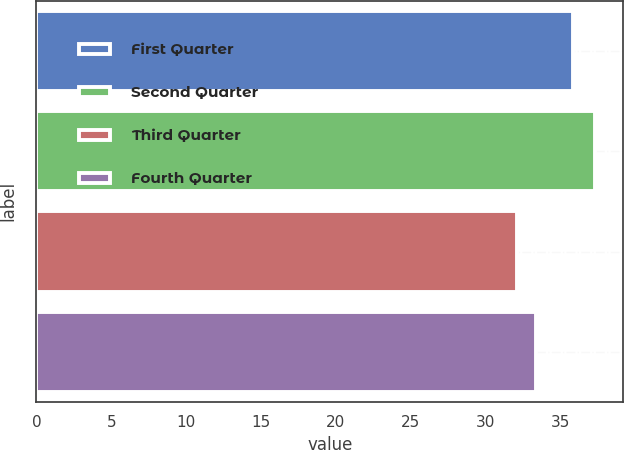Convert chart to OTSL. <chart><loc_0><loc_0><loc_500><loc_500><bar_chart><fcel>First Quarter<fcel>Second Quarter<fcel>Third Quarter<fcel>Fourth Quarter<nl><fcel>35.86<fcel>37.32<fcel>32.12<fcel>33.36<nl></chart> 